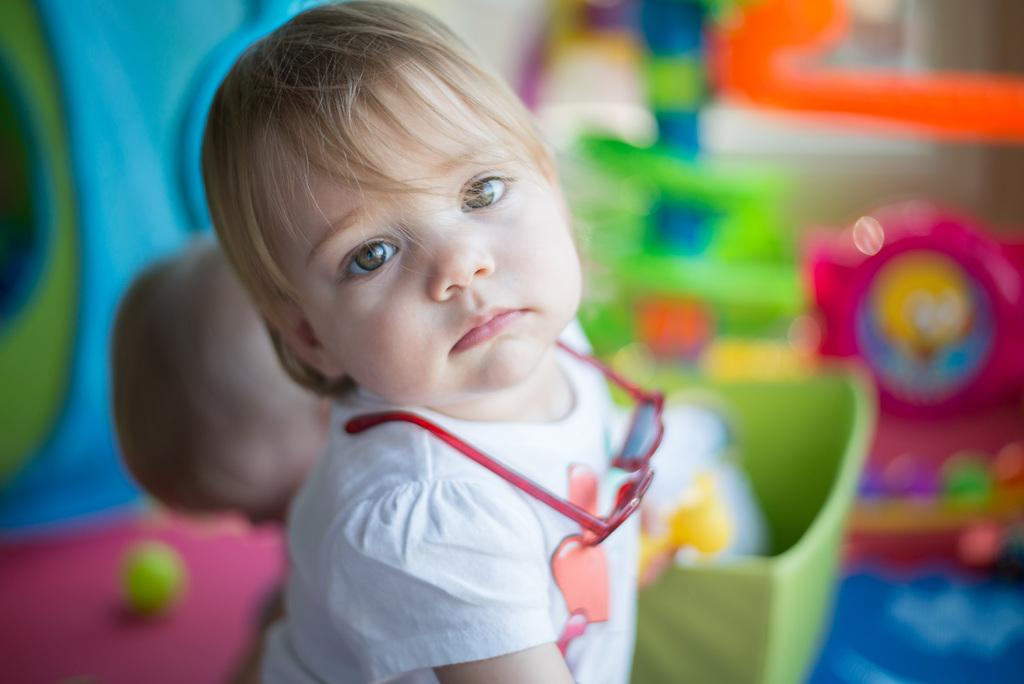What is the main subject of the picture? The main subject of the picture is a kid. What is the kid wearing on their upper body? The kid is wearing a white top. What type of eyewear is the kid wearing? The kid is wearing goggles. What can be seen in the background of the picture? There are toys in the background of the picture. How many geese are visible in the picture? There are no geese present in the picture; it features a kid wearing goggles and toys in the background. What type of coach is the kid using to play with the toys? There is no coach visible in the picture, and the toys do not require a coach for play. 